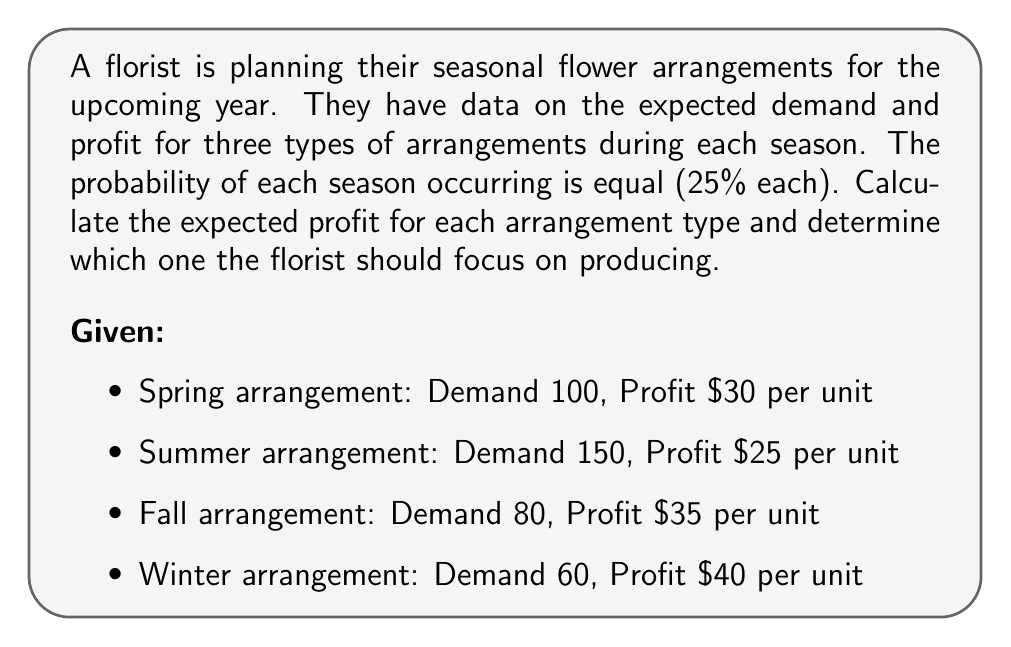Can you solve this math problem? To solve this problem, we need to calculate the expected profit for each arrangement type across all seasons. We'll use the concept of expected value from decision theory.

1. Calculate the profit for each arrangement in each season:
   Spring: $100 \times $30 = $3000$
   Summer: $150 \times $25 = $3750$
   Fall: $80 \times $35 = $2800$
   Winter: $60 \times $40 = $2400$

2. Calculate the expected profit for each arrangement:
   Let $E(P)$ be the expected profit.
   
   For each arrangement:
   $$E(P) = 0.25 \times P_{spring} + 0.25 \times P_{summer} + 0.25 \times P_{fall} + 0.25 \times P_{winter}$$

   Spring arrangement:
   $$E(P_{spring}) = 0.25 \times 3000 + 0.25 \times 3750 + 0.25 \times 2800 + 0.25 \times 2400$$
   $$E(P_{spring}) = 750 + 937.50 + 700 + 600 = $2987.50$$

   Summer arrangement:
   $$E(P_{summer}) = 0.25 \times 3750 + 0.25 \times 3750 + 0.25 \times 3750 + 0.25 \times 3750$$
   $$E(P_{summer}) = 937.50 + 937.50 + 937.50 + 937.50 = $3750$$

   Fall arrangement:
   $$E(P_{fall}) = 0.25 \times 2800 + 0.25 \times 3750 + 0.25 \times 2800 + 0.25 \times 2400$$
   $$E(P_{fall}) = 700 + 937.50 + 700 + 600 = $2937.50$$

   Winter arrangement:
   $$E(P_{winter}) = 0.25 \times 2400 + 0.25 \times 3750 + 0.25 \times 2800 + 0.25 \times 2400$$
   $$E(P_{winter}) = 600 + 937.50 + 700 + 600 = $2837.50$$

3. Compare the expected profits:
   Summer arrangement has the highest expected profit at $3750.
Answer: The expected profits for each arrangement are:
Spring: $2987.50
Summer: $3750.00
Fall: $2937.50
Winter: $2837.50

The florist should focus on producing the Summer arrangement, as it has the highest expected profit of $3750.00. 